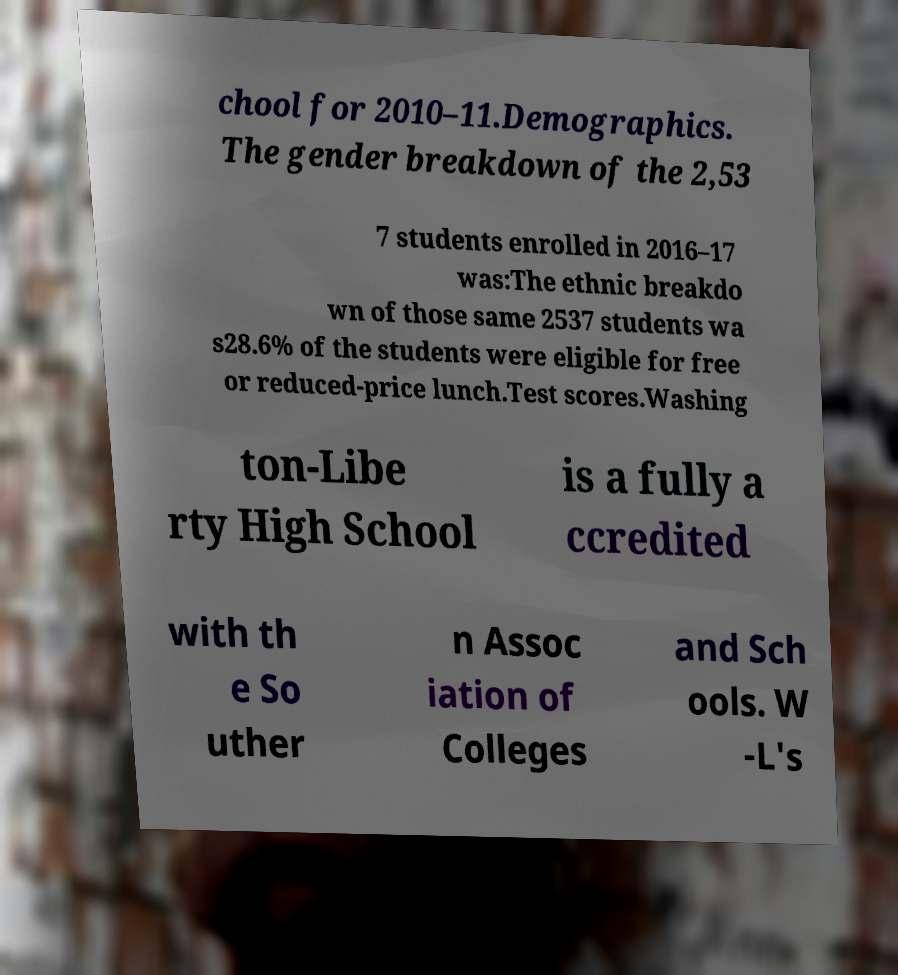I need the written content from this picture converted into text. Can you do that? chool for 2010–11.Demographics. The gender breakdown of the 2,53 7 students enrolled in 2016–17 was:The ethnic breakdo wn of those same 2537 students wa s28.6% of the students were eligible for free or reduced-price lunch.Test scores.Washing ton-Libe rty High School is a fully a ccredited with th e So uther n Assoc iation of Colleges and Sch ools. W -L's 